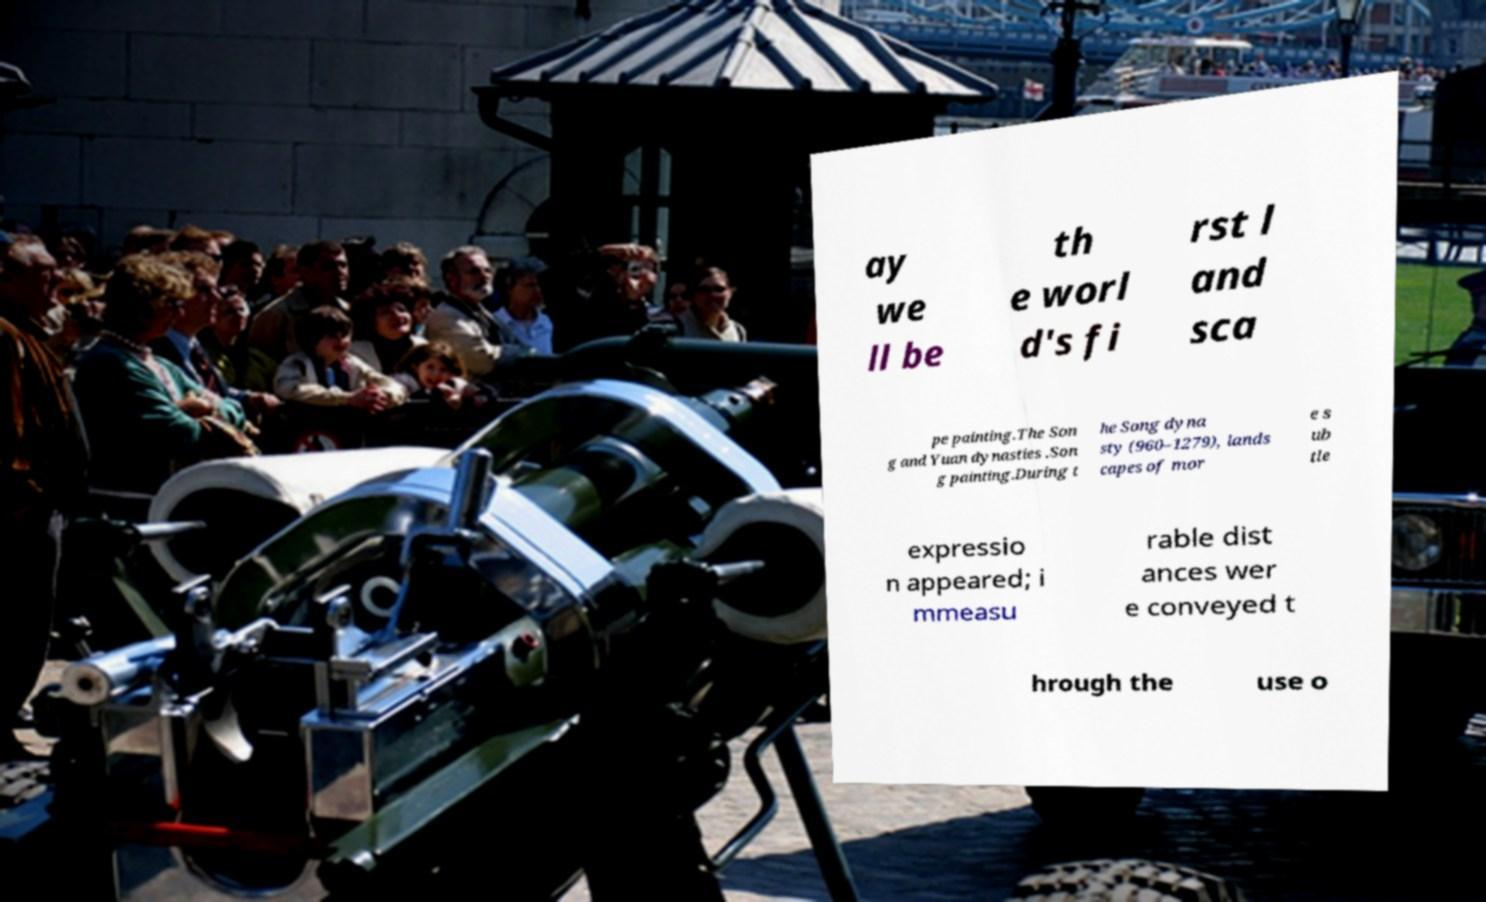There's text embedded in this image that I need extracted. Can you transcribe it verbatim? ay we ll be th e worl d's fi rst l and sca pe painting.The Son g and Yuan dynasties .Son g painting.During t he Song dyna sty (960–1279), lands capes of mor e s ub tle expressio n appeared; i mmeasu rable dist ances wer e conveyed t hrough the use o 